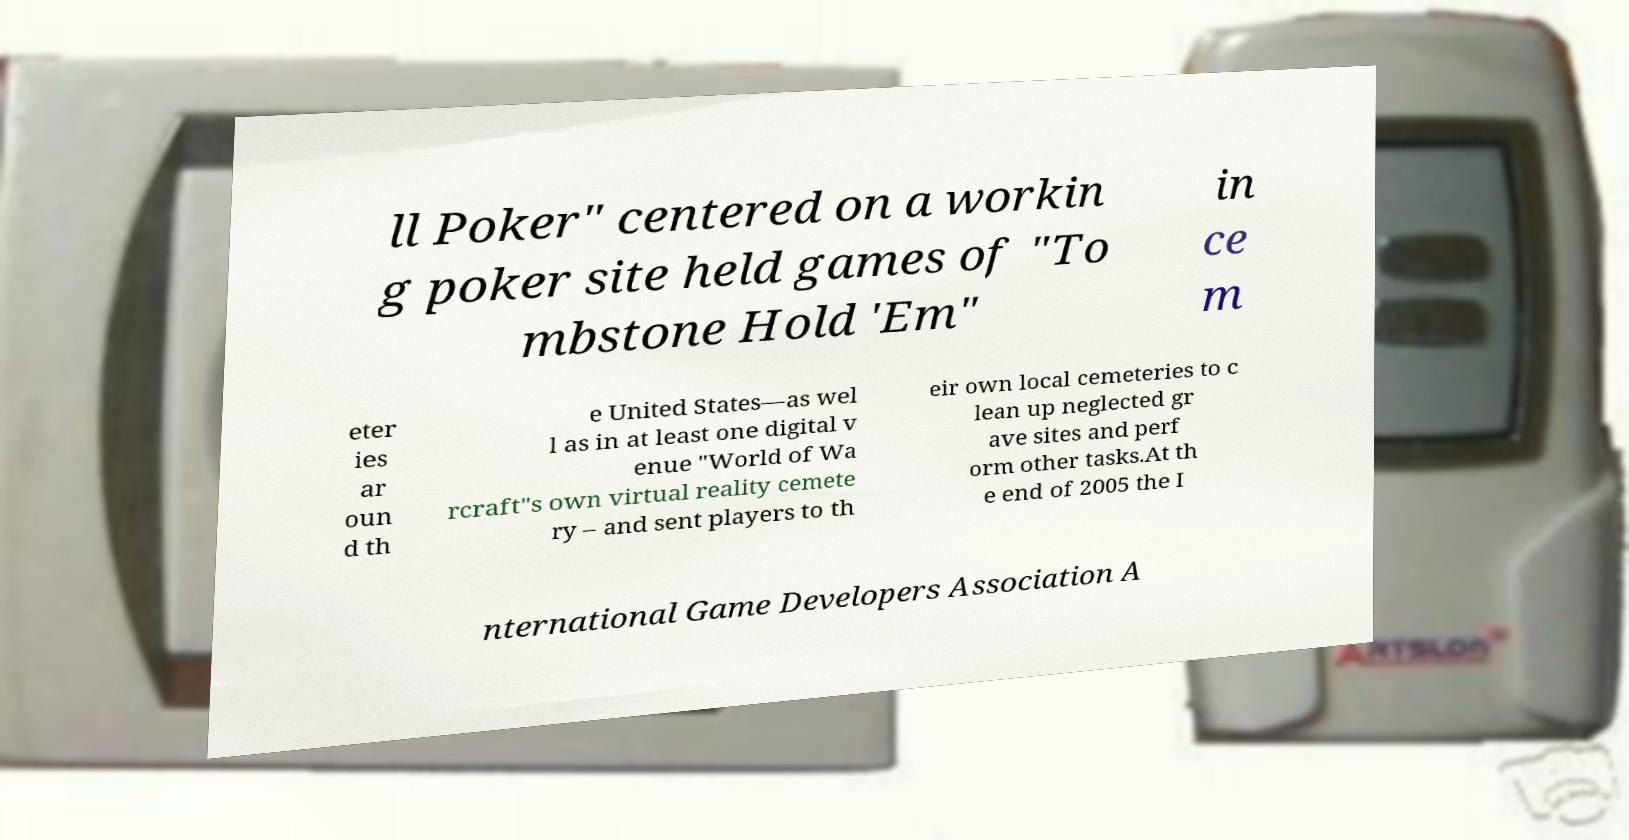Please identify and transcribe the text found in this image. ll Poker" centered on a workin g poker site held games of "To mbstone Hold 'Em" in ce m eter ies ar oun d th e United States—as wel l as in at least one digital v enue "World of Wa rcraft"s own virtual reality cemete ry – and sent players to th eir own local cemeteries to c lean up neglected gr ave sites and perf orm other tasks.At th e end of 2005 the I nternational Game Developers Association A 